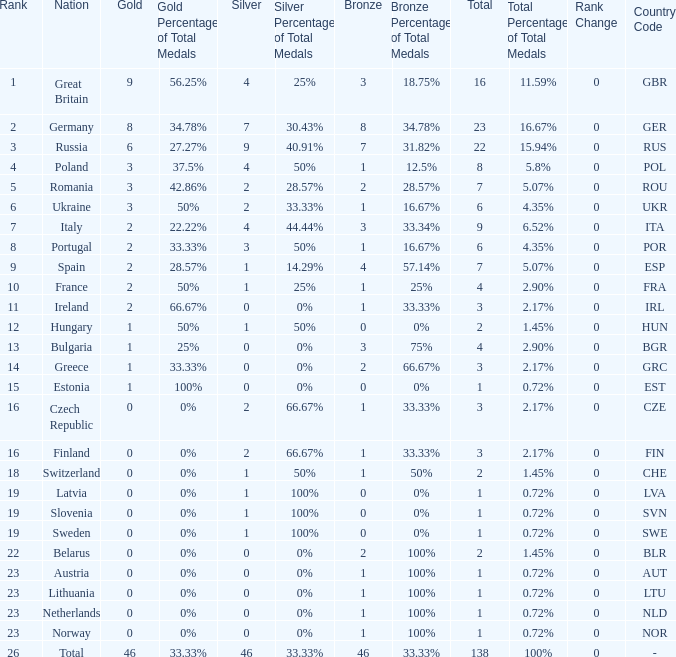What is the most bronze can be when silver is larger than 2, and the nation is germany, and gold is more than 8? None. 